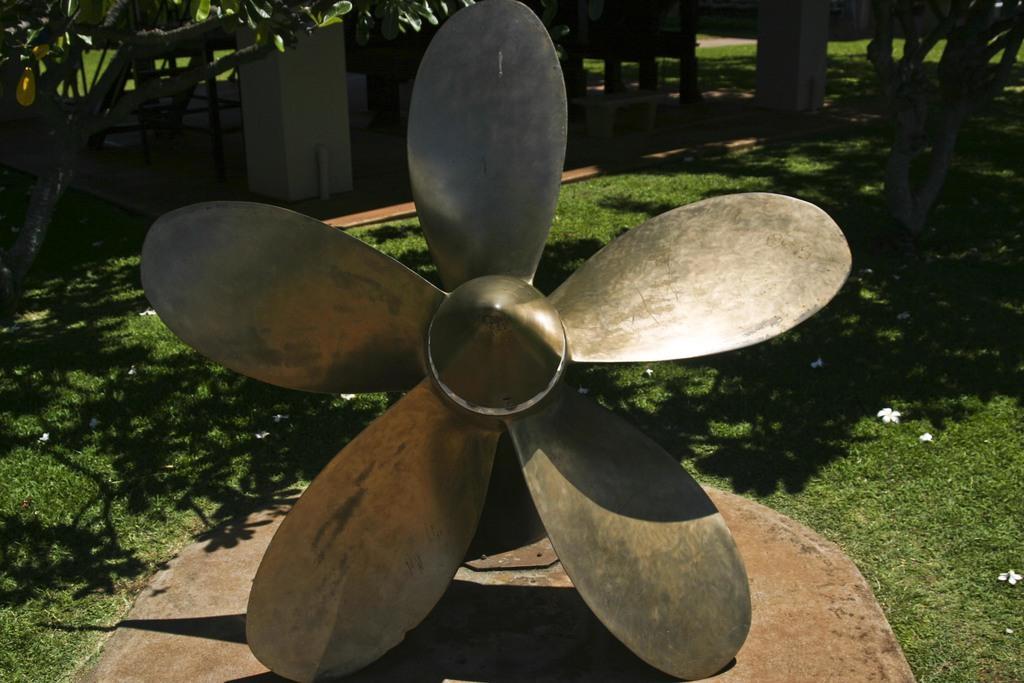In one or two sentences, can you explain what this image depicts? In the image we can see the metal fan on a solid surface. Here we can see grass and trees. Here we can see white flowers and bench. 